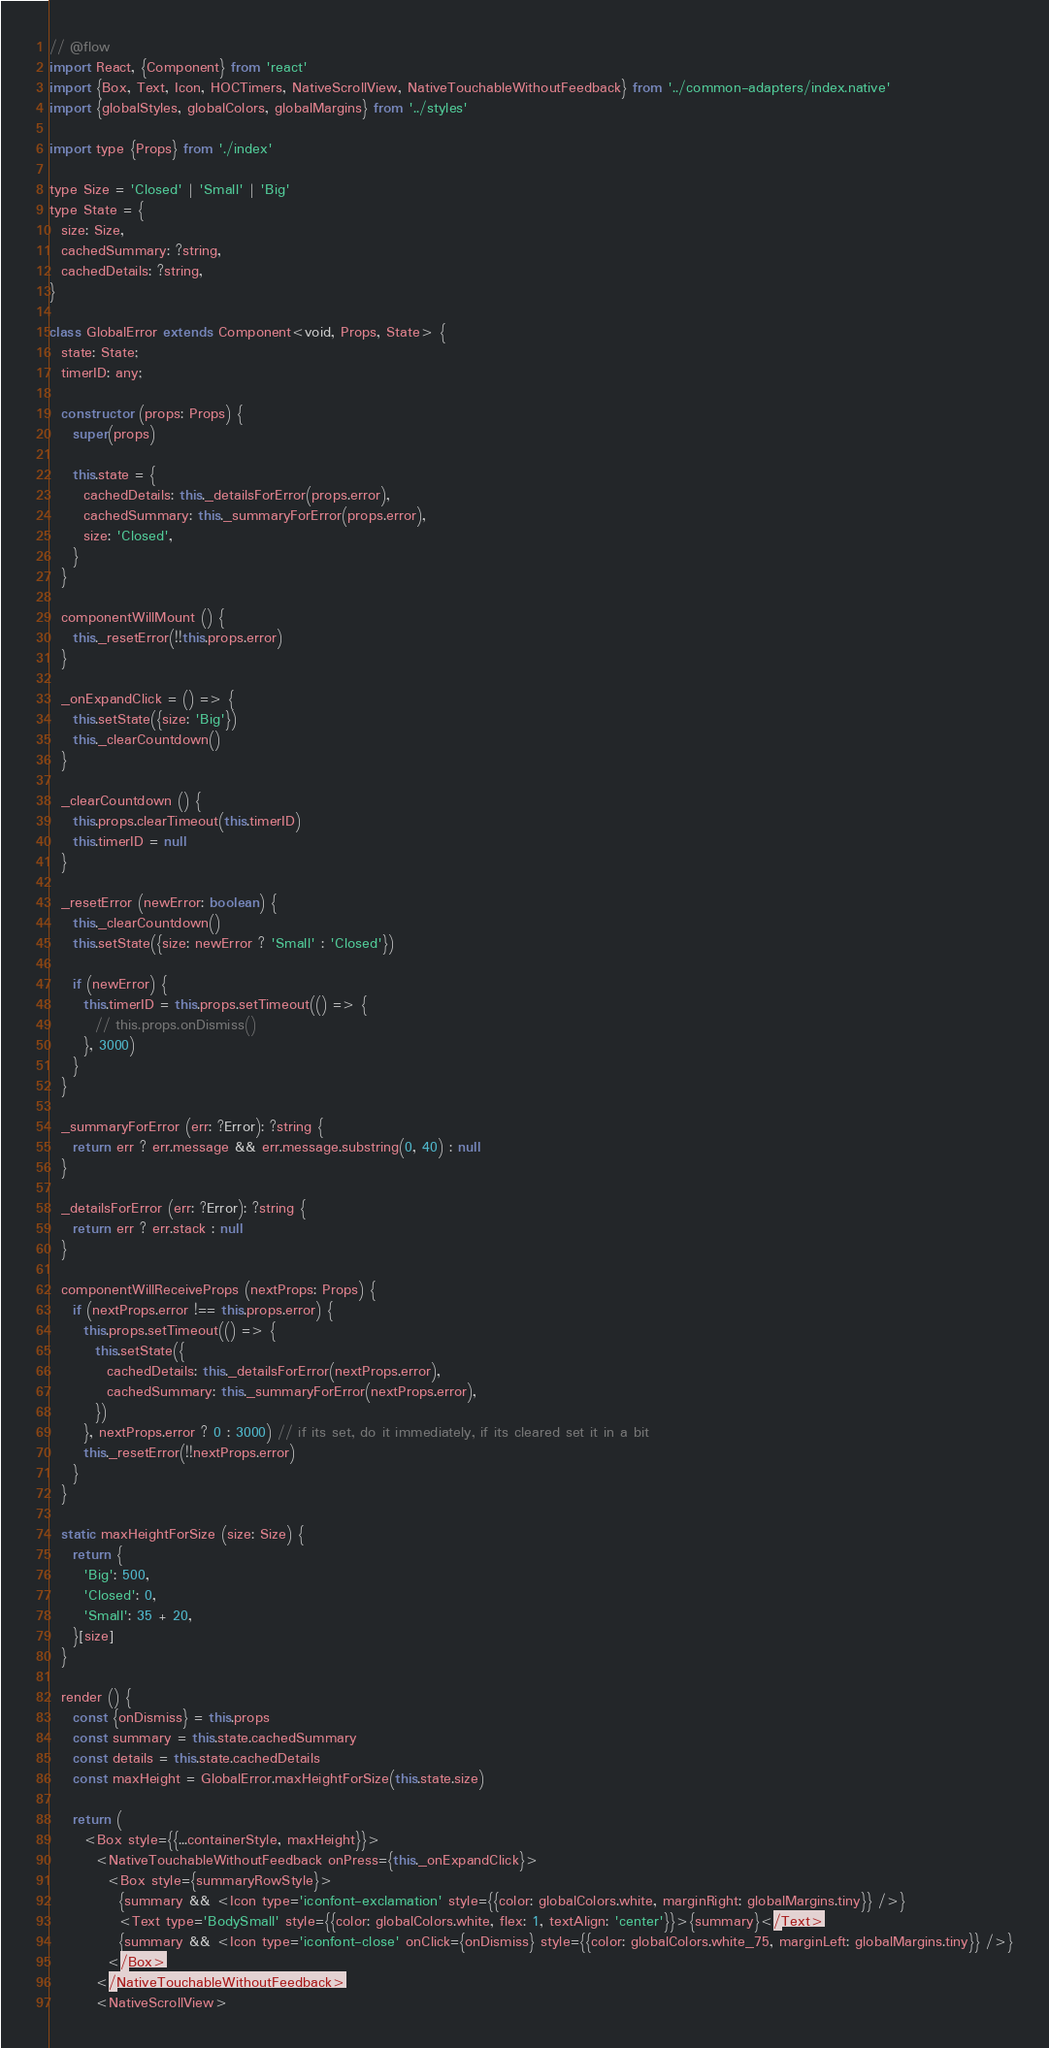Convert code to text. <code><loc_0><loc_0><loc_500><loc_500><_JavaScript_>// @flow
import React, {Component} from 'react'
import {Box, Text, Icon, HOCTimers, NativeScrollView, NativeTouchableWithoutFeedback} from '../common-adapters/index.native'
import {globalStyles, globalColors, globalMargins} from '../styles'

import type {Props} from './index'

type Size = 'Closed' | 'Small' | 'Big'
type State = {
  size: Size,
  cachedSummary: ?string,
  cachedDetails: ?string,
}

class GlobalError extends Component<void, Props, State> {
  state: State;
  timerID: any;

  constructor (props: Props) {
    super(props)

    this.state = {
      cachedDetails: this._detailsForError(props.error),
      cachedSummary: this._summaryForError(props.error),
      size: 'Closed',
    }
  }

  componentWillMount () {
    this._resetError(!!this.props.error)
  }

  _onExpandClick = () => {
    this.setState({size: 'Big'})
    this._clearCountdown()
  }

  _clearCountdown () {
    this.props.clearTimeout(this.timerID)
    this.timerID = null
  }

  _resetError (newError: boolean) {
    this._clearCountdown()
    this.setState({size: newError ? 'Small' : 'Closed'})

    if (newError) {
      this.timerID = this.props.setTimeout(() => {
        // this.props.onDismiss()
      }, 3000)
    }
  }

  _summaryForError (err: ?Error): ?string {
    return err ? err.message && err.message.substring(0, 40) : null
  }

  _detailsForError (err: ?Error): ?string {
    return err ? err.stack : null
  }

  componentWillReceiveProps (nextProps: Props) {
    if (nextProps.error !== this.props.error) {
      this.props.setTimeout(() => {
        this.setState({
          cachedDetails: this._detailsForError(nextProps.error),
          cachedSummary: this._summaryForError(nextProps.error),
        })
      }, nextProps.error ? 0 : 3000) // if its set, do it immediately, if its cleared set it in a bit
      this._resetError(!!nextProps.error)
    }
  }

  static maxHeightForSize (size: Size) {
    return {
      'Big': 500,
      'Closed': 0,
      'Small': 35 + 20,
    }[size]
  }

  render () {
    const {onDismiss} = this.props
    const summary = this.state.cachedSummary
    const details = this.state.cachedDetails
    const maxHeight = GlobalError.maxHeightForSize(this.state.size)

    return (
      <Box style={{...containerStyle, maxHeight}}>
        <NativeTouchableWithoutFeedback onPress={this._onExpandClick}>
          <Box style={summaryRowStyle}>
            {summary && <Icon type='iconfont-exclamation' style={{color: globalColors.white, marginRight: globalMargins.tiny}} />}
            <Text type='BodySmall' style={{color: globalColors.white, flex: 1, textAlign: 'center'}}>{summary}</Text>
            {summary && <Icon type='iconfont-close' onClick={onDismiss} style={{color: globalColors.white_75, marginLeft: globalMargins.tiny}} />}
          </Box>
        </NativeTouchableWithoutFeedback>
        <NativeScrollView></code> 